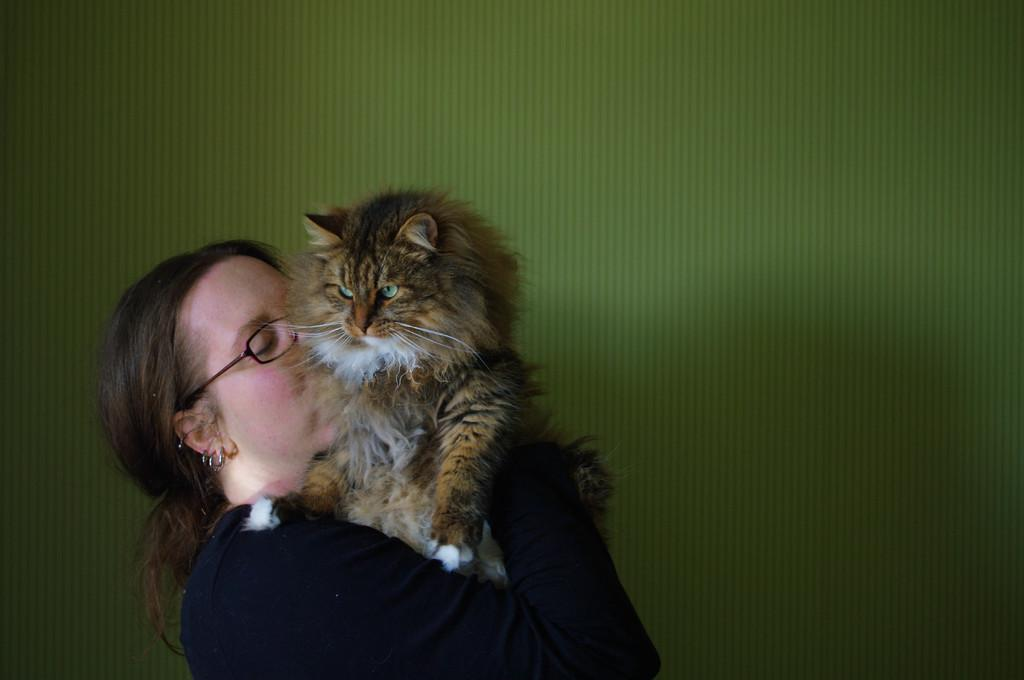Who is present in the image? There is a woman in the image. What is the woman wearing? The woman is wearing spectacles. What is the woman doing with the animal? The woman is holding and kissing the animal. What can be seen in the background of the image? There is a wall in the background of the image. What type of knife is the woman using to cut the rat in the image? There is no knife or rat present in the image. The woman is holding and kissing an animal, but it is not a rat, and she is not using a knife. 